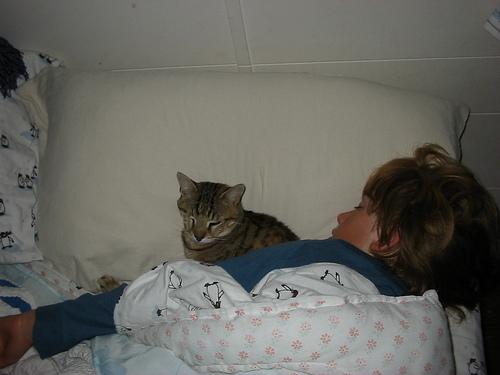What pattern is the comforter?
Give a very brief answer. Flowered. The generic name for these animals are named after which US President?
Answer briefly. Cat. Is the cat sleeping?
Be succinct. No. What animal can be seen?
Be succinct. Cat. Can you describe the cat's eyes?
Give a very brief answer. Closed. Are the kids related?
Give a very brief answer. No. What is the cat lying on?
Short answer required. Bed. What color is the cat?
Write a very short answer. Gray. Is the cat keeping the child company?
Concise answer only. Yes. What animal is represented?
Be succinct. Cat. Are the person's eyes open?
Keep it brief. No. What is the boy holding beneath his arm?
Answer briefly. Cat. Is the cat upside down?
Give a very brief answer. No. 